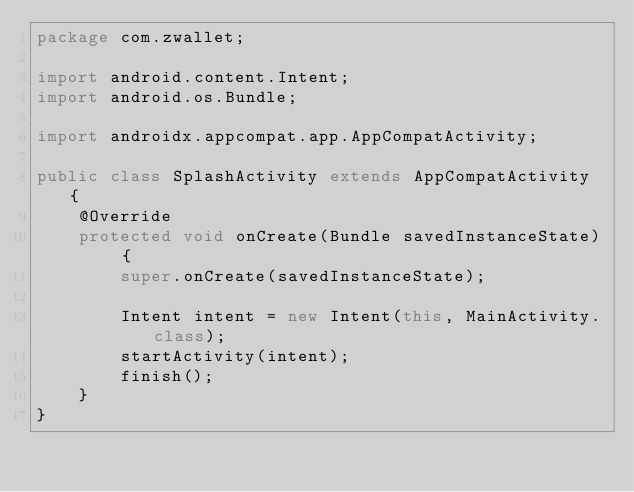Convert code to text. <code><loc_0><loc_0><loc_500><loc_500><_Java_>package com.zwallet; 

import android.content.Intent;
import android.os.Bundle;

import androidx.appcompat.app.AppCompatActivity;

public class SplashActivity extends AppCompatActivity {
    @Override
    protected void onCreate(Bundle savedInstanceState) {
        super.onCreate(savedInstanceState);

        Intent intent = new Intent(this, MainActivity.class);
        startActivity(intent);
        finish();
    }
}
</code> 